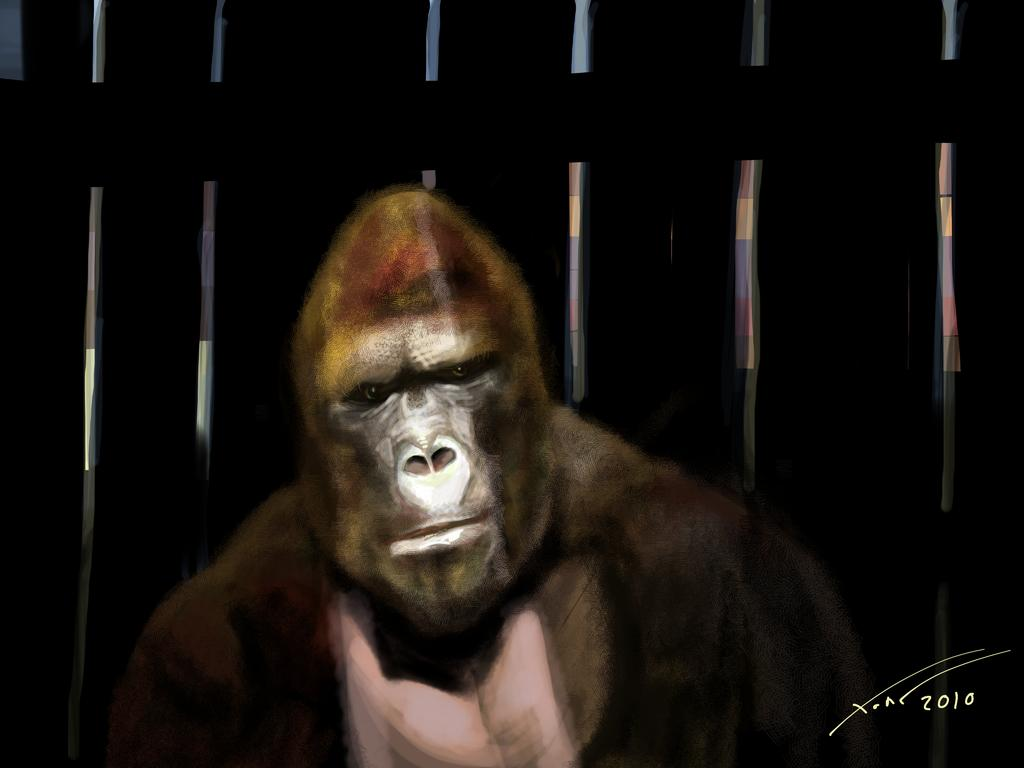What is the main subject of the painting in the image? The painting features a gorilla. Are there any other elements in the painting besides the gorilla? Yes, the painting also includes a fence. Where is the text located in the image? The text is at the bottom right side of the image. What type of heart can be seen beating in the painting? There is no heart visible in the painting; it features a gorilla and a fence. What school is depicted in the painting? The painting does not depict a school; it features a gorilla and a fence. 